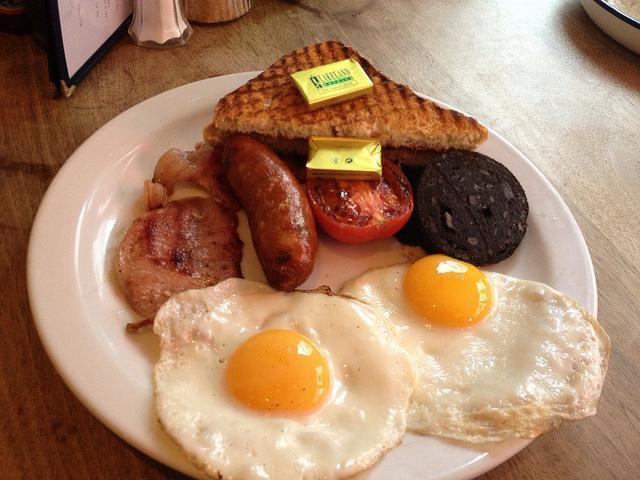How many eggs are served in this breakfast overeasy?
From the following four choices, select the correct answer to address the question.
Options: Four, three, two, five. Two. 